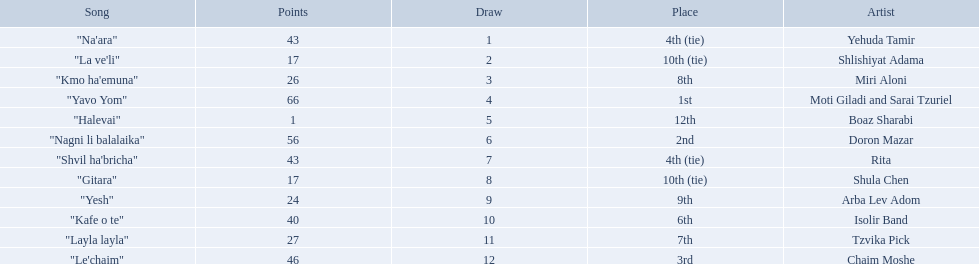What is the place of the contestant who received only 1 point? 12th. What is the name of the artist listed in the previous question? Boaz Sharabi. 